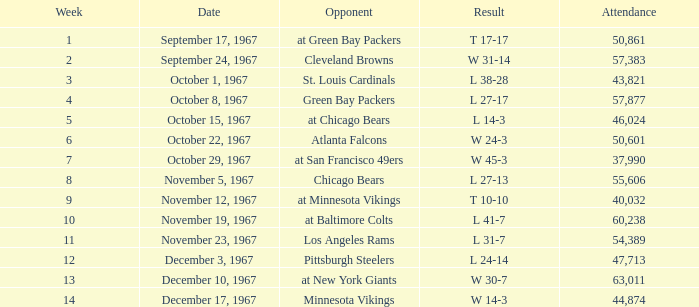Which Result has an Opponent of minnesota vikings? W 14-3. 